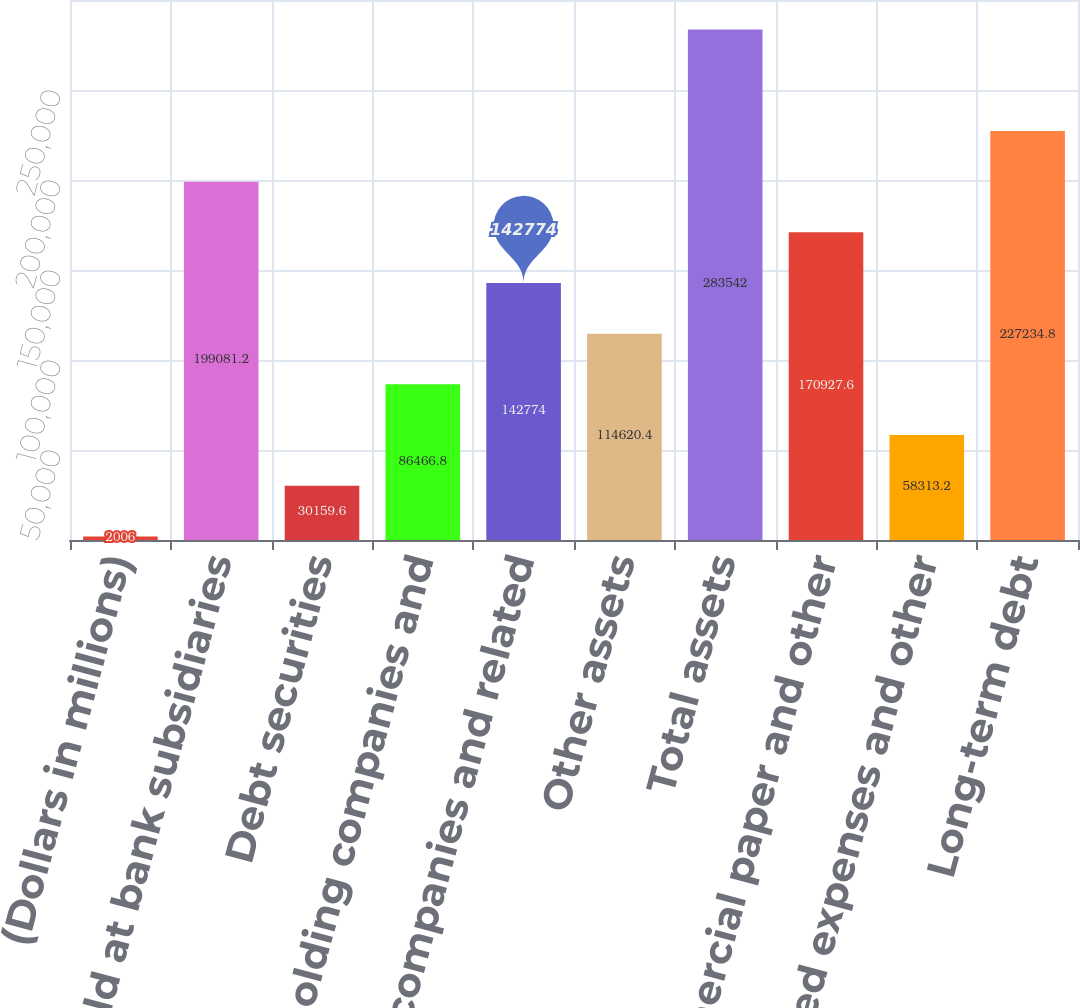Convert chart to OTSL. <chart><loc_0><loc_0><loc_500><loc_500><bar_chart><fcel>(Dollars in millions)<fcel>Cash held at bank subsidiaries<fcel>Debt securities<fcel>Bank holding companies and<fcel>Nonbank companies and related<fcel>Other assets<fcel>Total assets<fcel>Commercial paper and other<fcel>Accrued expenses and other<fcel>Long-term debt<nl><fcel>2006<fcel>199081<fcel>30159.6<fcel>86466.8<fcel>142774<fcel>114620<fcel>283542<fcel>170928<fcel>58313.2<fcel>227235<nl></chart> 